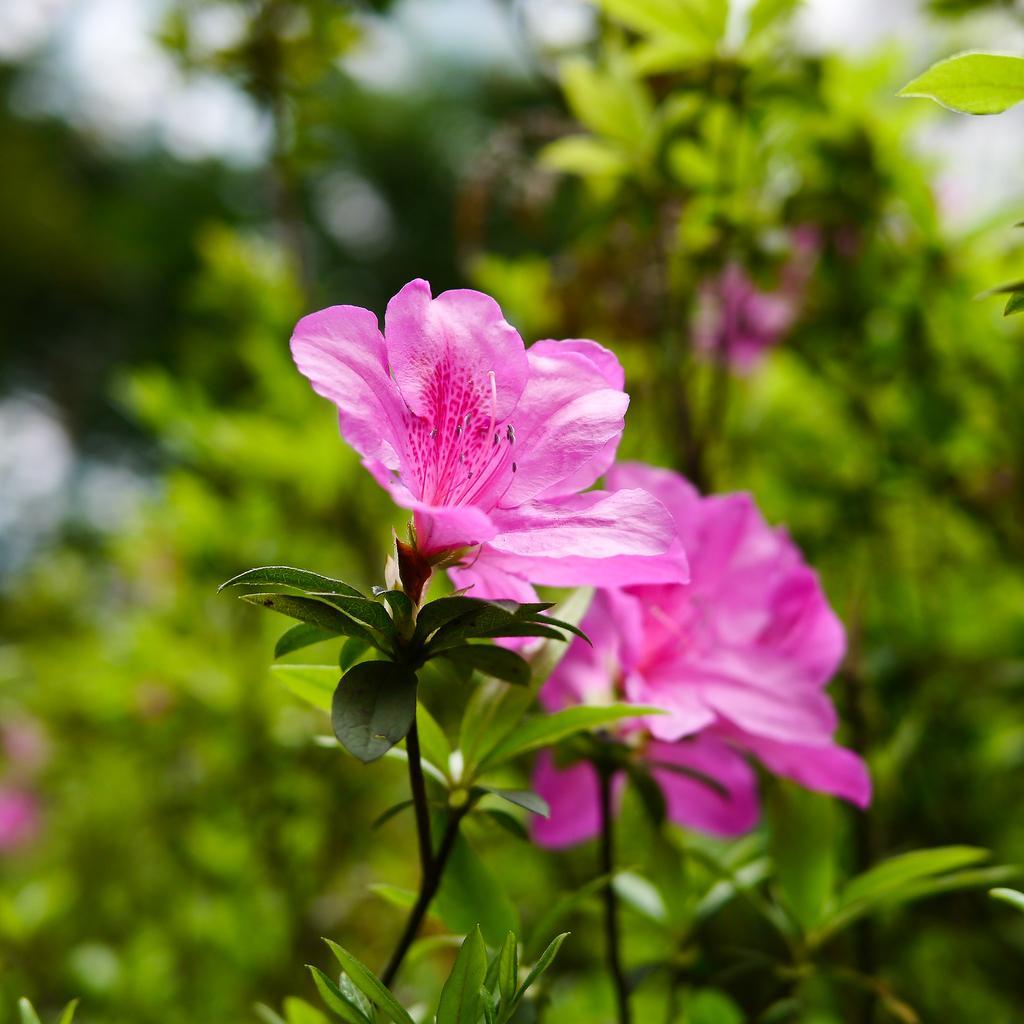Can you describe this image briefly? There are pink flower plants. 